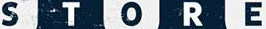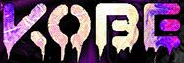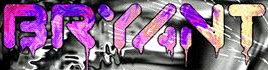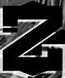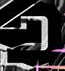What words can you see in these images in sequence, separated by a semicolon? STORE; KOBE; BRYANT; Z; D 